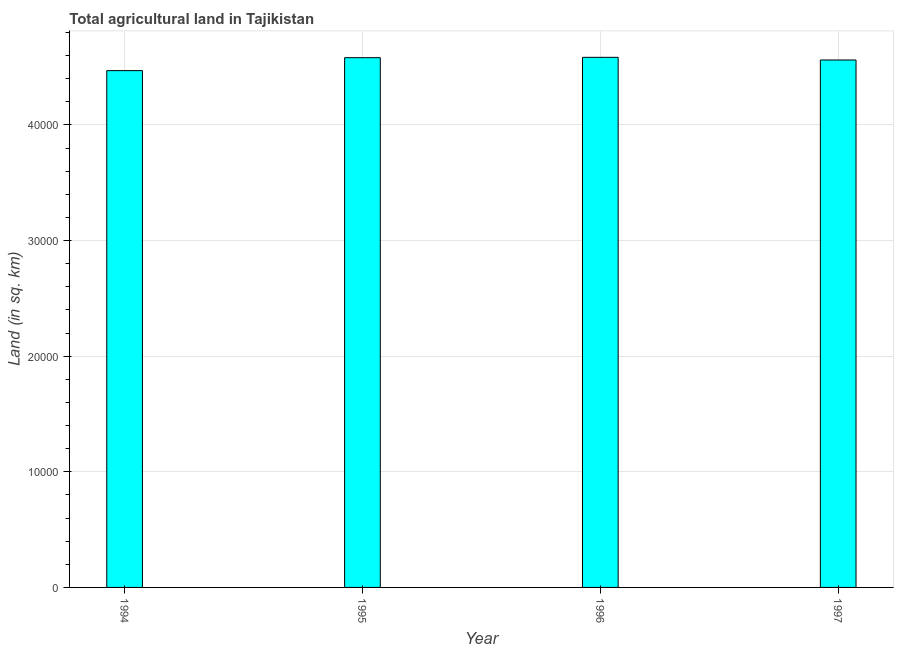Does the graph contain any zero values?
Keep it short and to the point. No. Does the graph contain grids?
Provide a succinct answer. Yes. What is the title of the graph?
Your response must be concise. Total agricultural land in Tajikistan. What is the label or title of the X-axis?
Keep it short and to the point. Year. What is the label or title of the Y-axis?
Offer a terse response. Land (in sq. km). What is the agricultural land in 1994?
Your answer should be compact. 4.47e+04. Across all years, what is the maximum agricultural land?
Offer a terse response. 4.58e+04. Across all years, what is the minimum agricultural land?
Offer a very short reply. 4.47e+04. In which year was the agricultural land maximum?
Provide a short and direct response. 1996. What is the sum of the agricultural land?
Offer a terse response. 1.82e+05. What is the difference between the agricultural land in 1994 and 1995?
Keep it short and to the point. -1120. What is the average agricultural land per year?
Give a very brief answer. 4.55e+04. What is the median agricultural land?
Offer a terse response. 4.57e+04. In how many years, is the agricultural land greater than 2000 sq. km?
Provide a succinct answer. 4. What is the ratio of the agricultural land in 1994 to that in 1996?
Keep it short and to the point. 0.97. Is the difference between the agricultural land in 1996 and 1997 greater than the difference between any two years?
Keep it short and to the point. No. What is the difference between the highest and the second highest agricultural land?
Your response must be concise. 30. Is the sum of the agricultural land in 1994 and 1997 greater than the maximum agricultural land across all years?
Give a very brief answer. Yes. What is the difference between the highest and the lowest agricultural land?
Give a very brief answer. 1150. How many bars are there?
Make the answer very short. 4. What is the difference between two consecutive major ticks on the Y-axis?
Provide a short and direct response. 10000. Are the values on the major ticks of Y-axis written in scientific E-notation?
Your response must be concise. No. What is the Land (in sq. km) in 1994?
Give a very brief answer. 4.47e+04. What is the Land (in sq. km) in 1995?
Offer a terse response. 4.58e+04. What is the Land (in sq. km) in 1996?
Offer a terse response. 4.58e+04. What is the Land (in sq. km) in 1997?
Offer a very short reply. 4.56e+04. What is the difference between the Land (in sq. km) in 1994 and 1995?
Offer a very short reply. -1120. What is the difference between the Land (in sq. km) in 1994 and 1996?
Your answer should be compact. -1150. What is the difference between the Land (in sq. km) in 1994 and 1997?
Your answer should be very brief. -920. What is the difference between the Land (in sq. km) in 1996 and 1997?
Your response must be concise. 230. What is the ratio of the Land (in sq. km) in 1994 to that in 1995?
Your answer should be very brief. 0.98. What is the ratio of the Land (in sq. km) in 1994 to that in 1996?
Give a very brief answer. 0.97. What is the ratio of the Land (in sq. km) in 1996 to that in 1997?
Give a very brief answer. 1. 